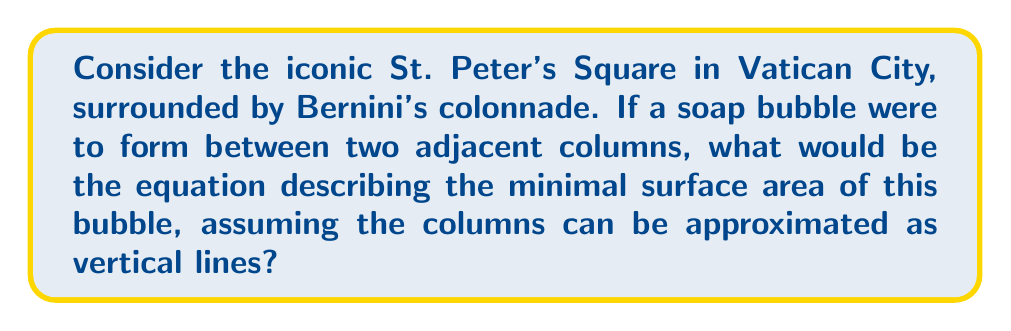Could you help me with this problem? To solve this problem, we'll follow these steps:

1) The minimal surface area formed by a soap bubble between two vertical lines is called a catenoid. This surface minimizes the area while maintaining constant mean curvature.

2) The equation of a catenoid in Cartesian coordinates is:

   $$z = a \cosh(\frac{x}{a})$$

   where $a$ is a constant that determines the shape of the catenoid.

3) To find the specific equation for our case, we need to consider the dimensions of the colonnade. Let's assume the distance between two adjacent columns is $2d$ and the height of the columns is $h$.

4) The boundary conditions for our catenoid are:
   
   At $x = -d$ and $x = d$, $z = h$

5) Substituting these into our general equation:

   $$h = a \cosh(\frac{d}{a})$$

6) This transcendental equation can be solved numerically for $a$ given specific values of $d$ and $h$.

7) Once we have $a$, the complete equation of the minimal surface area (catenoid) formed by the soap bubble between the columns is:

   $$z = a \cosh(\frac{x}{a}), \quad -d \leq x \leq d, \quad 0 \leq z \leq h$$

8) The surface area of this catenoid can be calculated using the formula:

   $$A = 2\pi a^2 \left[\sinh(\frac{d}{a}) \cosh(\frac{d}{a}) - \frac{d}{a}\right]$$

This equation provides the minimal surface area of the soap bubble formed between the architectural arches of the Vatican's colonnade.
Answer: $$z = a \cosh(\frac{x}{a}), \quad \text{where } h = a \cosh(\frac{d}{a})$$ 